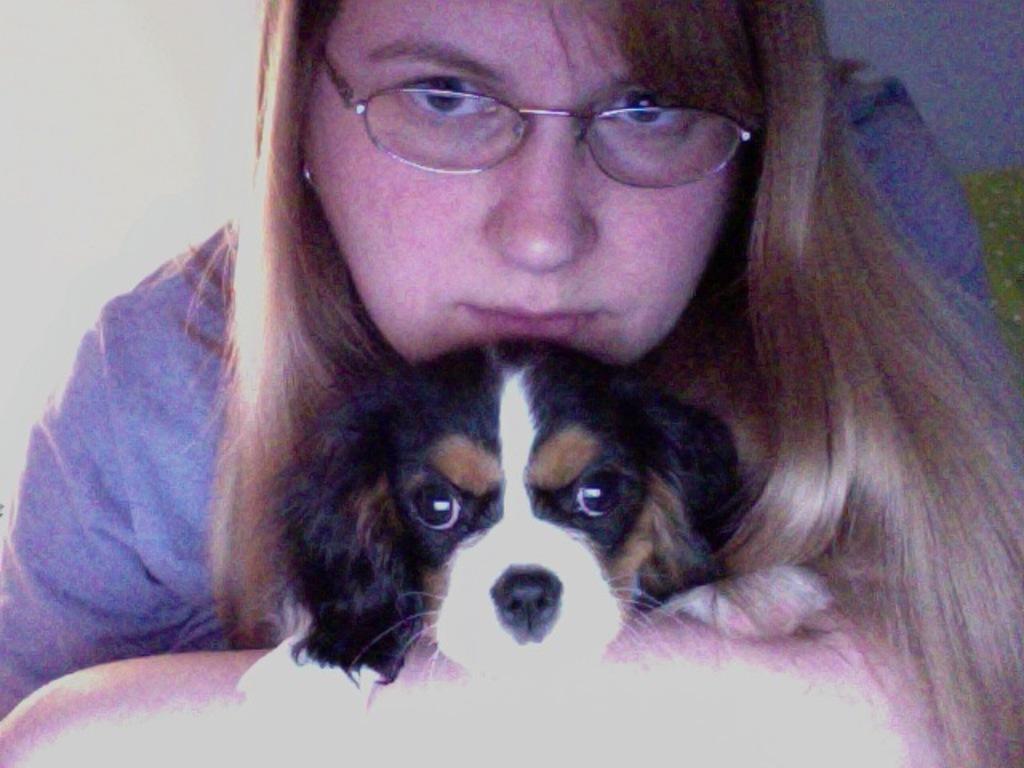Describe this image in one or two sentences. In this image I can see a dog. I can see a woman. In the background, I can see the wall. 